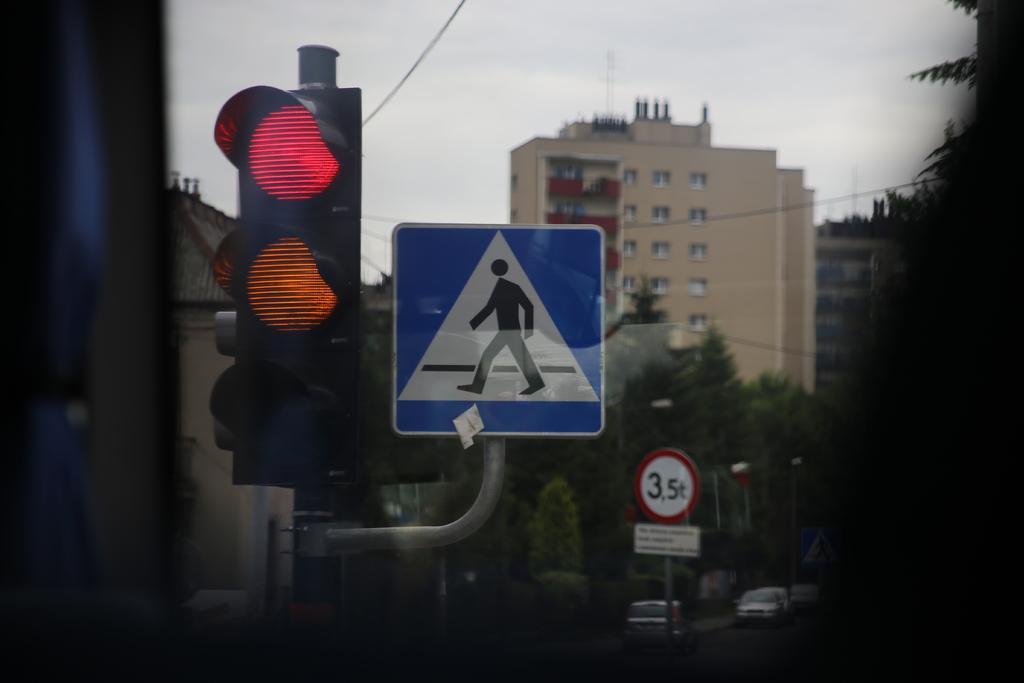Could you give a brief overview of what you see in this image? In this picture we can see the poles with traffic signals and boards. Behind the poles there are vehicles on the road and behind the vehicles there are trees, cables, buildings and the sky. 